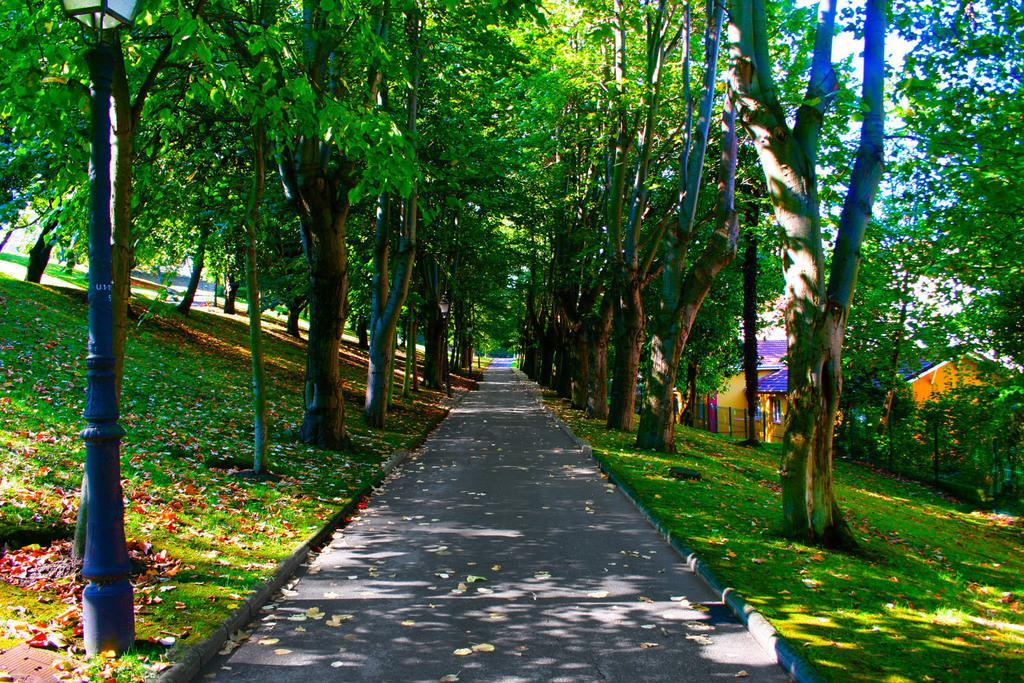In one or two sentences, can you explain what this image depicts? In this picture we can see leaves on the road, grass, trees, pole with a light, fence, houses and in the background we can see the sky. 